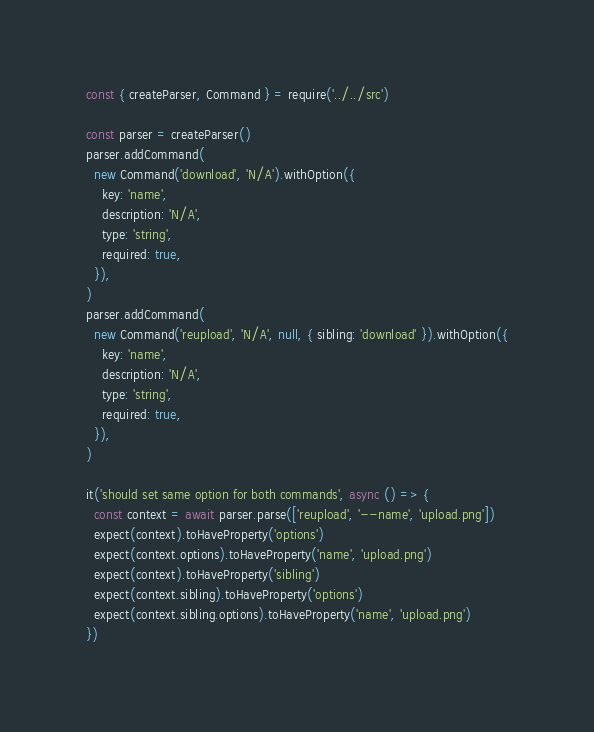Convert code to text. <code><loc_0><loc_0><loc_500><loc_500><_JavaScript_>const { createParser, Command } = require('../../src')

const parser = createParser()
parser.addCommand(
  new Command('download', 'N/A').withOption({
    key: 'name',
    description: 'N/A',
    type: 'string',
    required: true,
  }),
)
parser.addCommand(
  new Command('reupload', 'N/A', null, { sibling: 'download' }).withOption({
    key: 'name',
    description: 'N/A',
    type: 'string',
    required: true,
  }),
)

it('should set same option for both commands', async () => {
  const context = await parser.parse(['reupload', '--name', 'upload.png'])
  expect(context).toHaveProperty('options')
  expect(context.options).toHaveProperty('name', 'upload.png')
  expect(context).toHaveProperty('sibling')
  expect(context.sibling).toHaveProperty('options')
  expect(context.sibling.options).toHaveProperty('name', 'upload.png')
})
</code> 